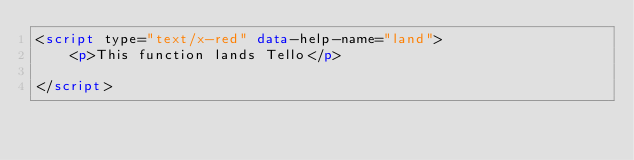Convert code to text. <code><loc_0><loc_0><loc_500><loc_500><_HTML_><script type="text/x-red" data-help-name="land">
    <p>This function lands Tello</p>

</script>

</code> 